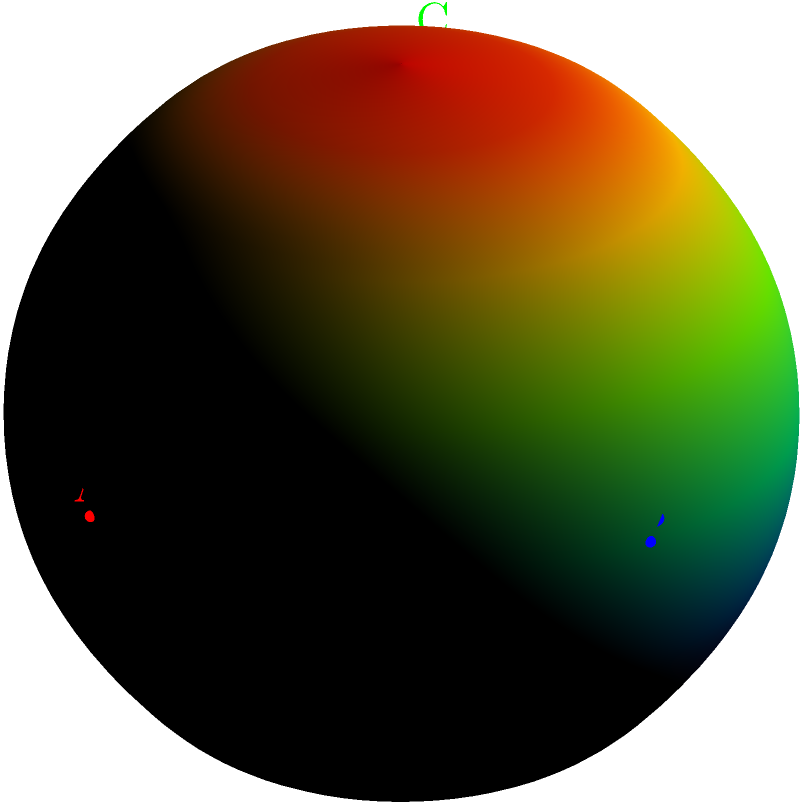In a groundbreaking study on extinct species genetics, researchers have mapped genetic markers on a spherical coordinate system representing Earth. Three significant markers (A, B, and C) have been identified at the following coordinates:

A: $(r, \theta, \phi) = (2, \frac{\pi}{2}, 0)$
B: $(r, \theta, \phi) = (2, \frac{\pi}{2}, \frac{\pi}{2})$
C: $(r, \theta, \phi) = (2, \frac{\pi}{4}, \frac{5\pi}{4})$

If these markers represent potential locations for extracting preserved DNA of extinct species (like in Jurassic Park), which marker is located closest to the Earth's core, and what is its distance from the center in terms of $\pi$? To solve this problem, we need to understand spherical coordinates and how they relate to distance from the Earth's center. In spherical coordinates:

1. $r$ represents the distance from the origin (Earth's center)
2. $\theta$ (theta) represents the polar angle from the z-axis (0 to $\pi$)
3. $\phi$ (phi) represents the azimuthal angle in the x-y plane (0 to $2\pi$)

Let's analyze each point:

1. Point A: $(2, \frac{\pi}{2}, 0)$
   - $r = 2$, so it's 2 units from the center

2. Point B: $(2, \frac{\pi}{2}, \frac{\pi}{2})$
   - $r = 2$, so it's also 2 units from the center

3. Point C: $(2, \frac{\pi}{4}, \frac{5\pi}{4})$
   - $r = 2$, but $\theta = \frac{\pi}{4}$

The key here is $\theta$. A smaller $\theta$ means the point is closer to the positive z-axis, which in this case means closer to the Earth's core.

Point C has the smallest $\theta$ value ($\frac{\pi}{4}$), so it's closest to the Earth's core.

The distance from the center for point C is given by its $r$ value, which is 2.

To express this in terms of $\pi$, we can set up the proportion:
$$\frac{2}{\pi} = \frac{x}{1}$$

Solving for $x$:
$$x = \frac{2}{\pi}$$

Therefore, the distance of point C from the Earth's center is $\frac{2}{\pi}$ in terms of $\pi$.
Answer: C, $\frac{2}{\pi}$ 